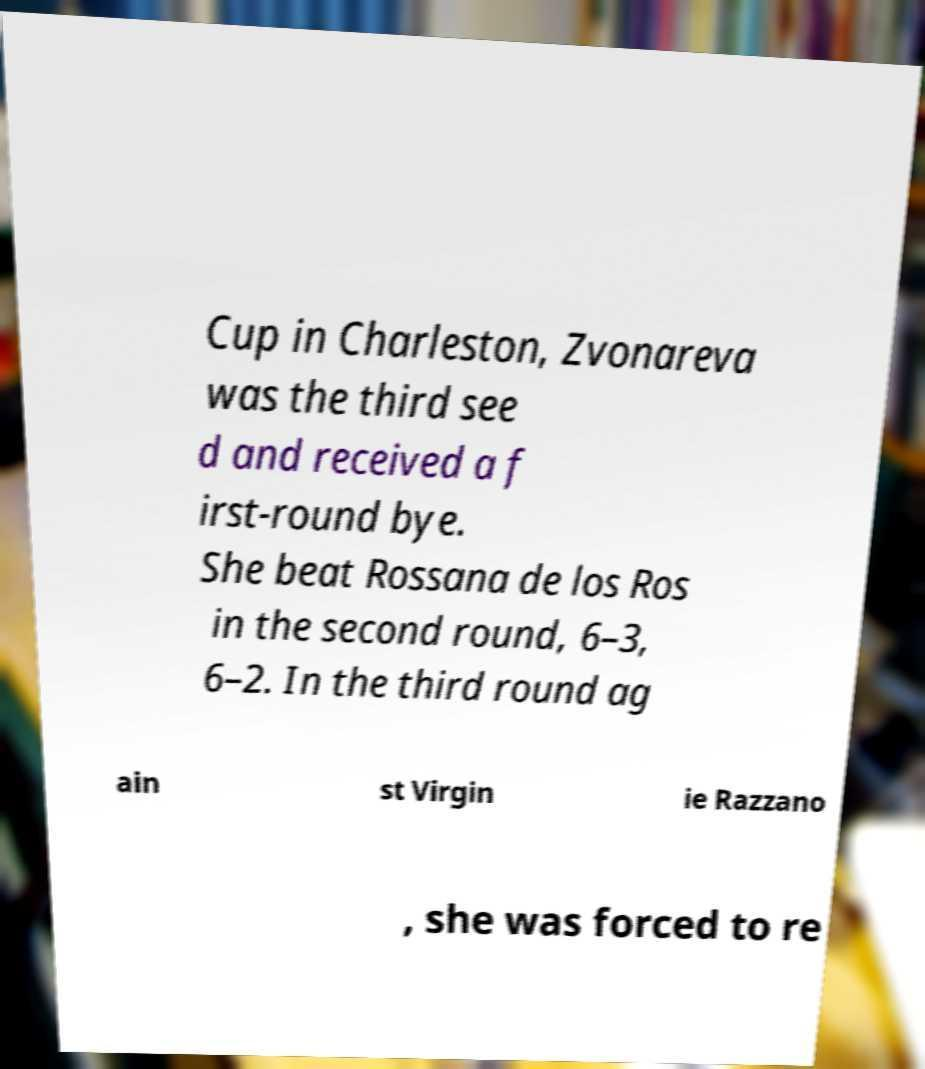I need the written content from this picture converted into text. Can you do that? Cup in Charleston, Zvonareva was the third see d and received a f irst-round bye. She beat Rossana de los Ros in the second round, 6–3, 6–2. In the third round ag ain st Virgin ie Razzano , she was forced to re 